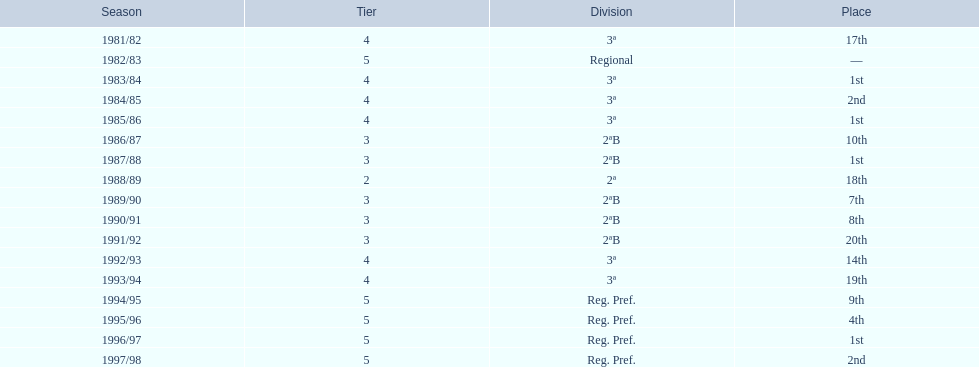Which year has no position pointed out? 1982/83. 